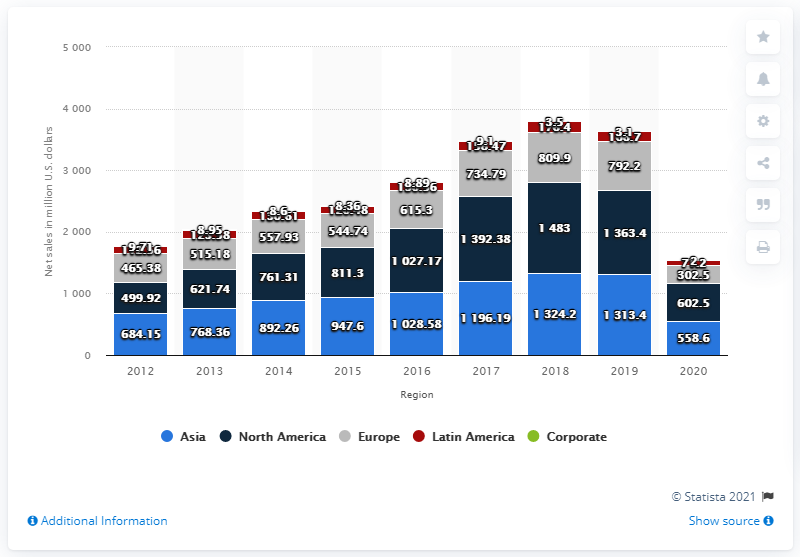List a handful of essential elements in this visual. Samsonite generated approximately $602.5 million in revenue in North America in 2020. 